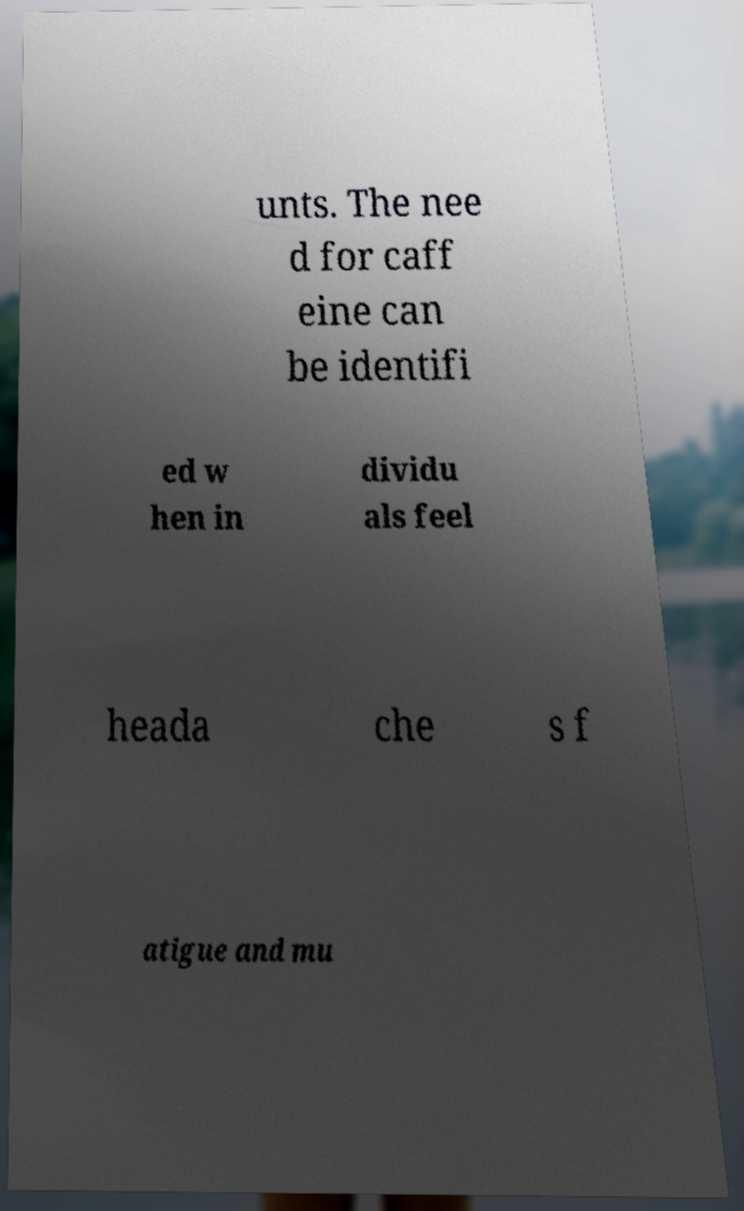Could you assist in decoding the text presented in this image and type it out clearly? unts. The nee d for caff eine can be identifi ed w hen in dividu als feel heada che s f atigue and mu 